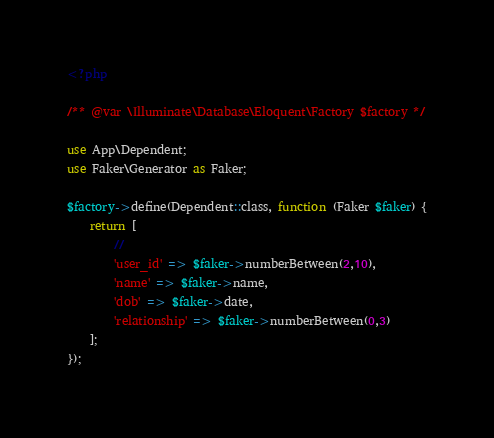<code> <loc_0><loc_0><loc_500><loc_500><_PHP_><?php

/** @var \Illuminate\Database\Eloquent\Factory $factory */

use App\Dependent;
use Faker\Generator as Faker;

$factory->define(Dependent::class, function (Faker $faker) {
    return [
        //
        'user_id' => $faker->numberBetween(2,10),
        'name' => $faker->name,
        'dob' => $faker->date,
        'relationship' => $faker->numberBetween(0,3)
    ];
});
</code> 